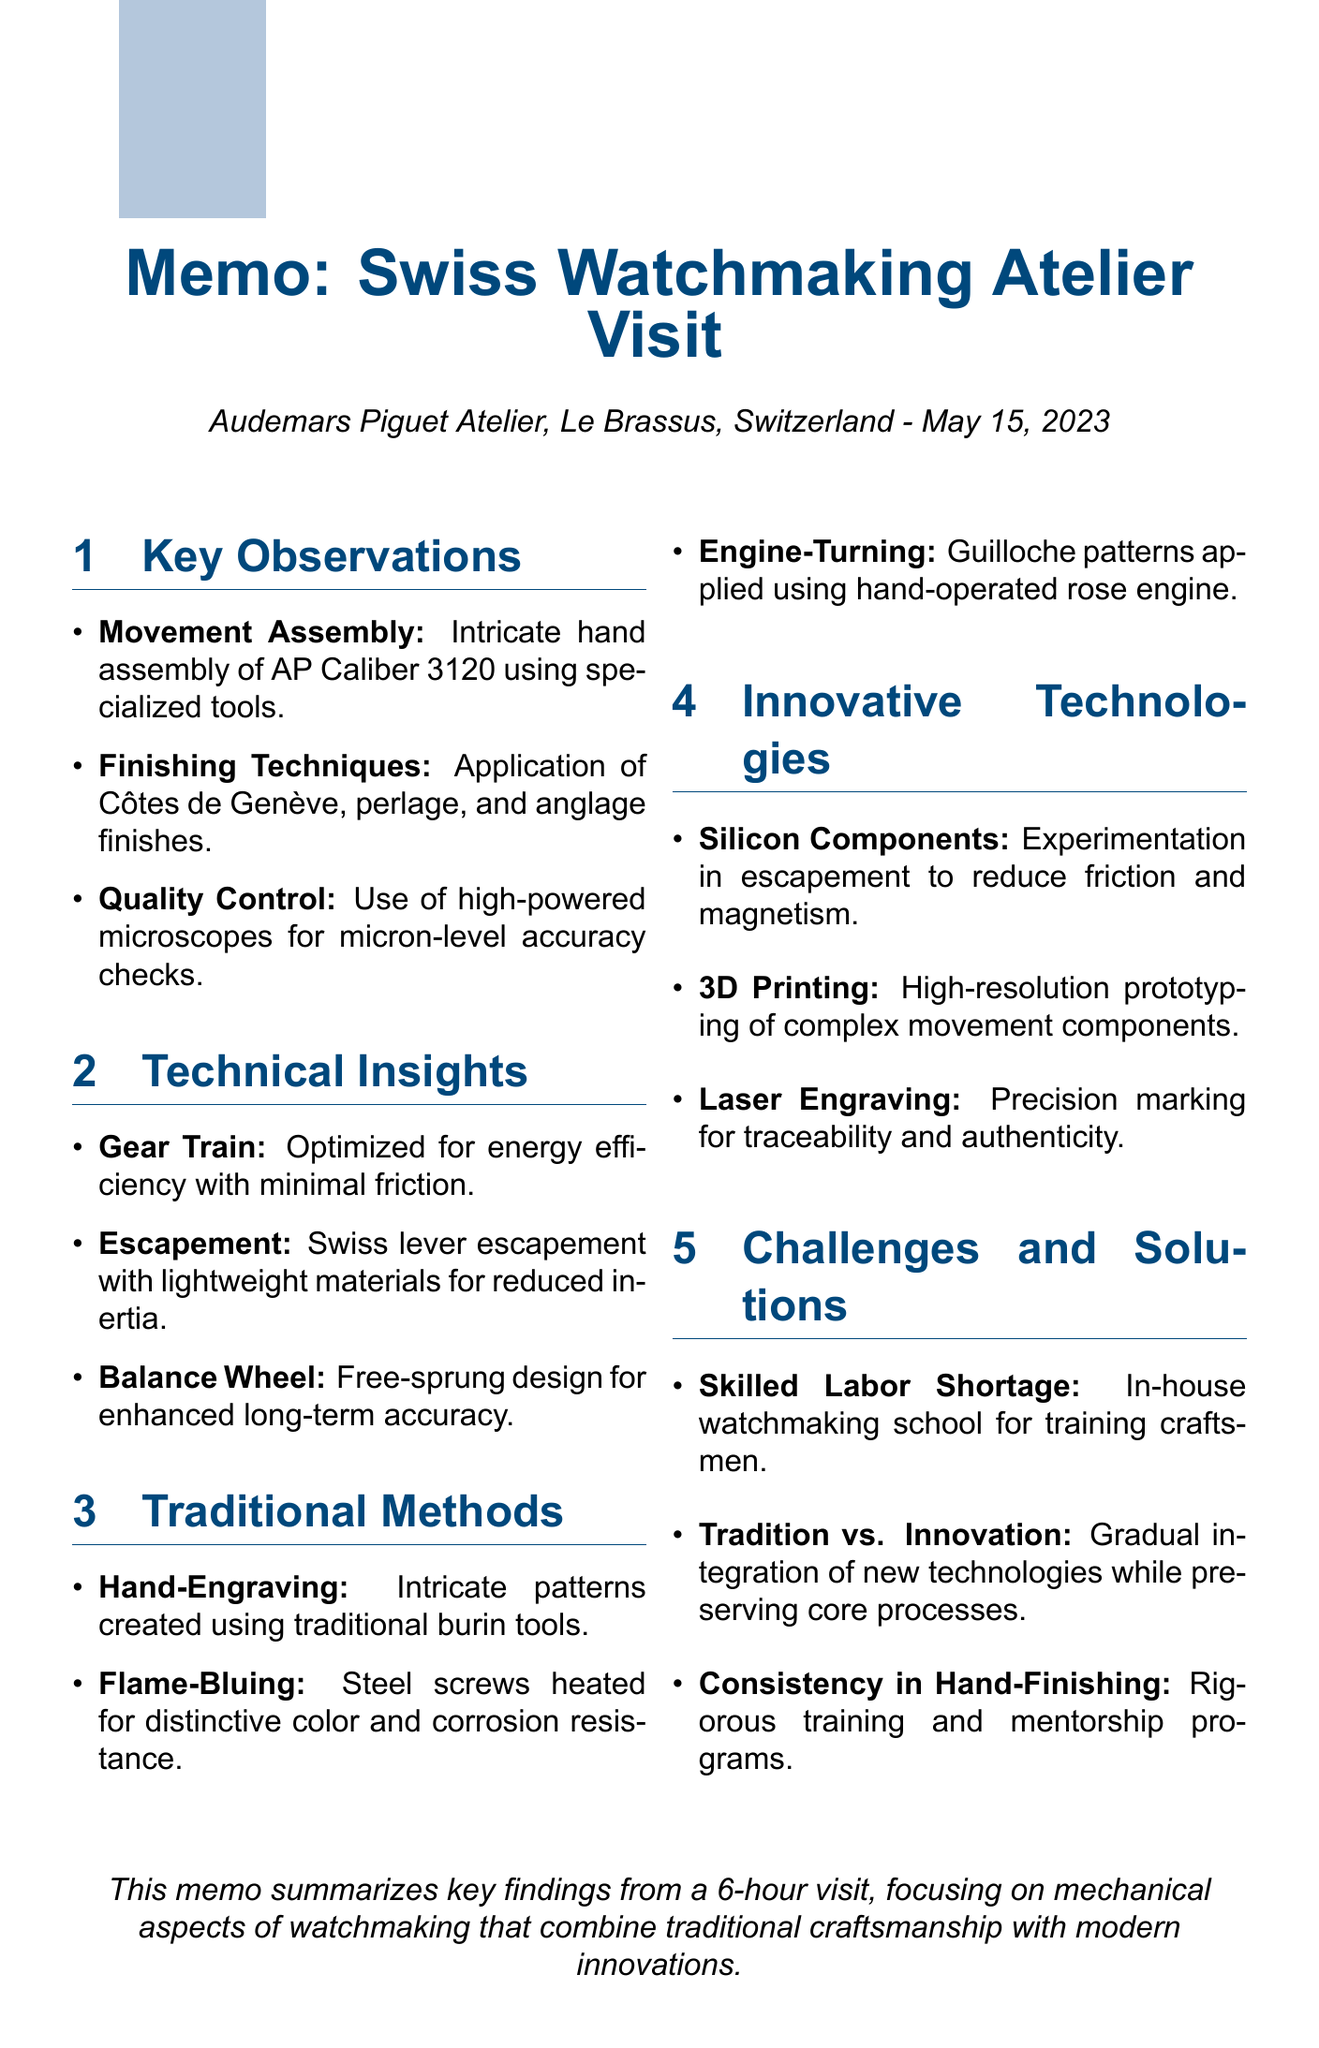What is the date of the visit? The date of the visit is specified in the document, which states May 15, 2023.
Answer: May 15, 2023 How long did the visit last? The duration of the visit is mentioned in the document as 6 hours.
Answer: 6 hours Which movement was observed during the assembly? The document specifies that the AP Caliber 3120 movement was assembled during the visit.
Answer: AP Caliber 3120 What finishing technique was applied to movement components? The document lists Côtes de Genève, perlage, and anglage as the finishing techniques observed.
Answer: Côtes de Genève, perlage, and anglage What challenge regarding skilled labor was identified? The document mentions the skilled labor shortage as a challenge faced by the atelier.
Answer: Skilled Labor Shortage What technique is used for creating intricate patterns on movement bridges? The traditional method of creating intricate patterns is hand-engraving.
Answer: Hand-Engraving What innovative technology is being experimented with to reduce friction in escapements? The document refers to the use of silicon components in escapements for this purpose.
Answer: Silicon Components What is a specific example of quality control used during assembly? The document notes the use of high-powered microscopes for quality checks at various stages of assembly.
Answer: High-powered microscopes Which traditional technique is described as dating back to the 16th century? The technique applied to dials using a rose engine is noted as dating back to the 16th century.
Answer: Engine-Turning 